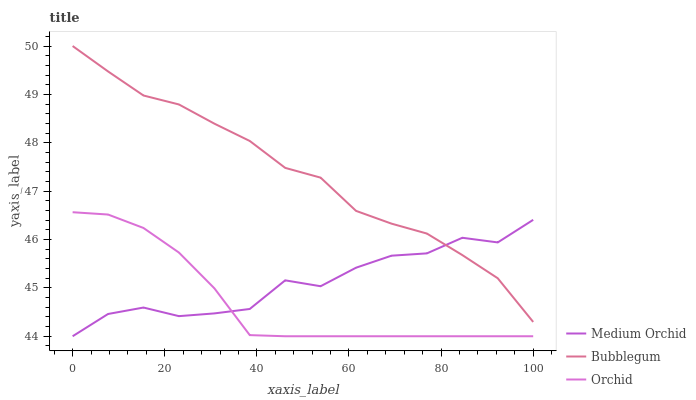Does Orchid have the minimum area under the curve?
Answer yes or no. Yes. Does Bubblegum have the maximum area under the curve?
Answer yes or no. Yes. Does Bubblegum have the minimum area under the curve?
Answer yes or no. No. Does Orchid have the maximum area under the curve?
Answer yes or no. No. Is Orchid the smoothest?
Answer yes or no. Yes. Is Medium Orchid the roughest?
Answer yes or no. Yes. Is Bubblegum the smoothest?
Answer yes or no. No. Is Bubblegum the roughest?
Answer yes or no. No. Does Medium Orchid have the lowest value?
Answer yes or no. Yes. Does Bubblegum have the lowest value?
Answer yes or no. No. Does Bubblegum have the highest value?
Answer yes or no. Yes. Does Orchid have the highest value?
Answer yes or no. No. Is Orchid less than Bubblegum?
Answer yes or no. Yes. Is Bubblegum greater than Orchid?
Answer yes or no. Yes. Does Orchid intersect Medium Orchid?
Answer yes or no. Yes. Is Orchid less than Medium Orchid?
Answer yes or no. No. Is Orchid greater than Medium Orchid?
Answer yes or no. No. Does Orchid intersect Bubblegum?
Answer yes or no. No. 